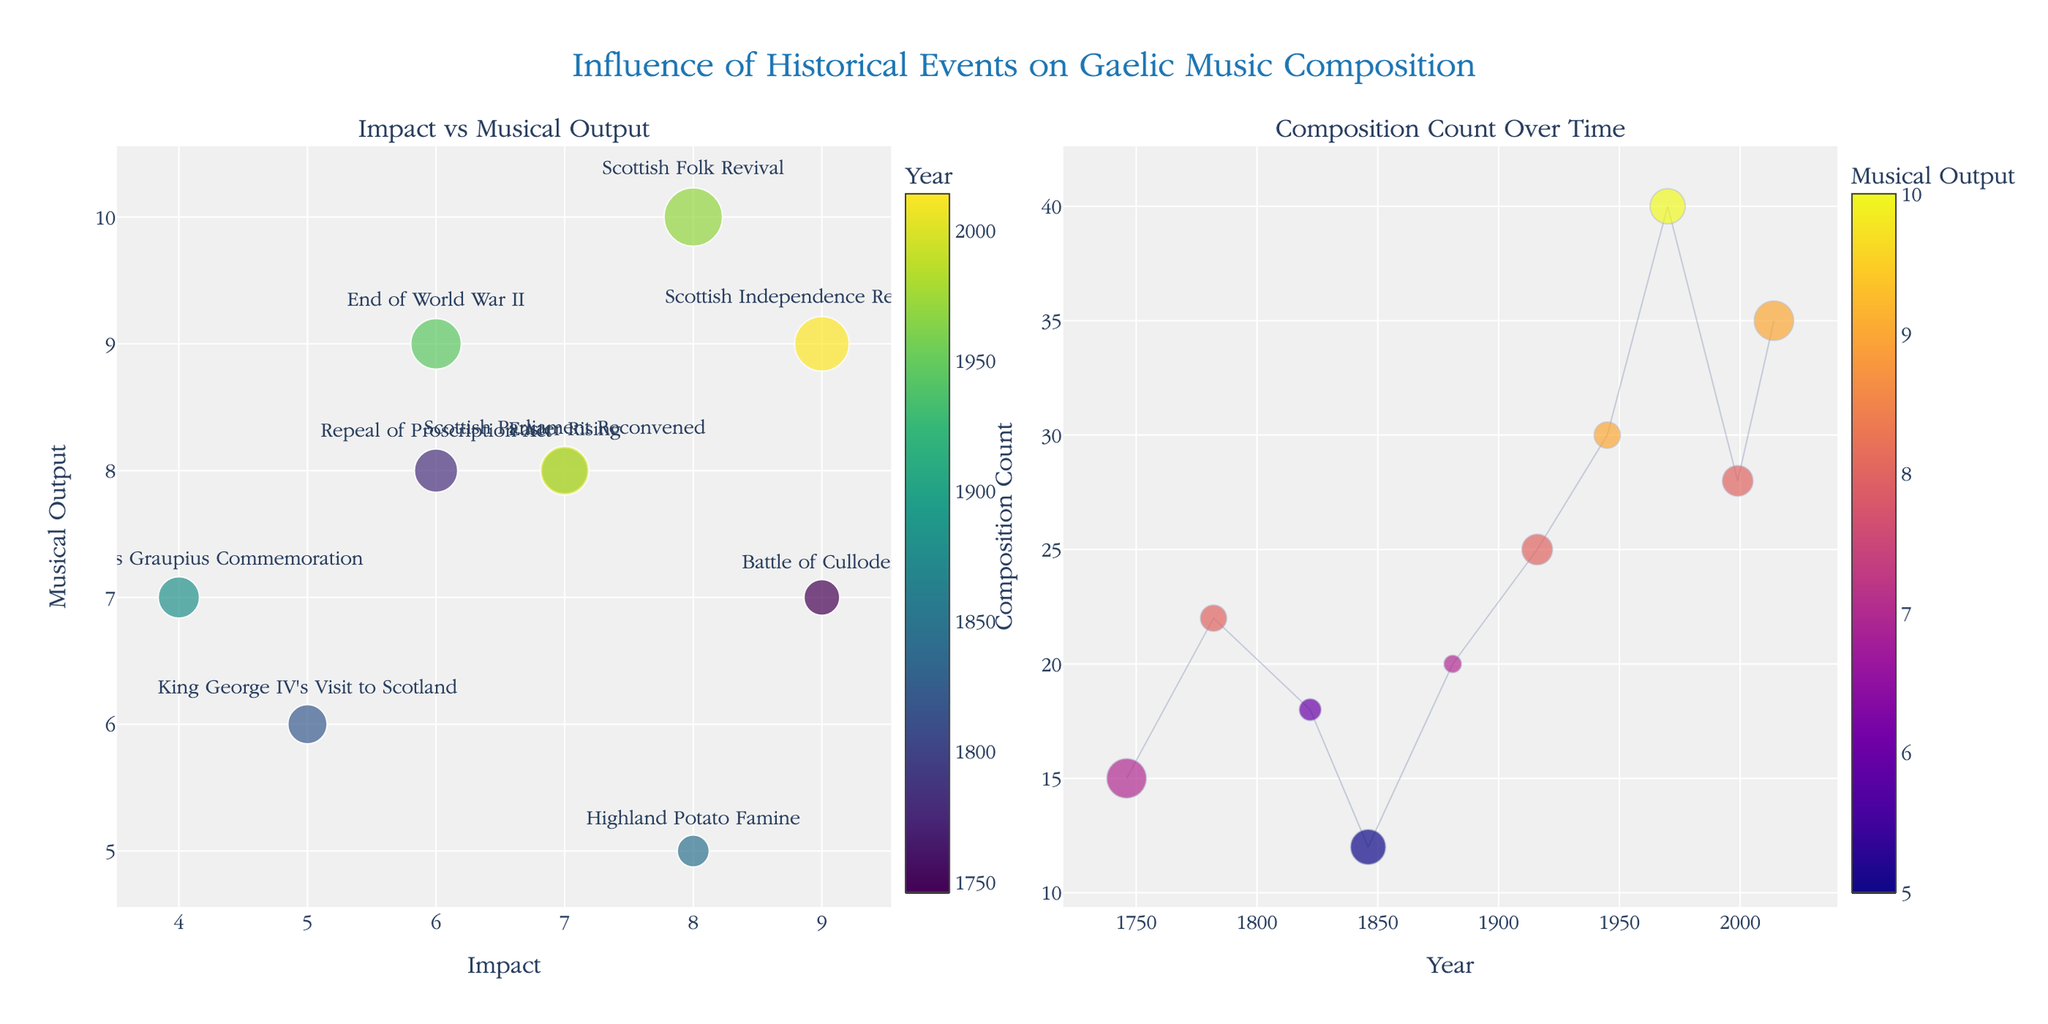What's the title of the figure? The title is displayed at the top center of the figure and reads, "Influence of Historical Events on Gaelic Music Composition".
Answer: Influence of Historical Events on Gaelic Music Composition Which event had the highest musical output? From the first subplot where "Musical Output" is on the y-axis, the event with the highest y-position is "Scottish Folk Revival" in 1970.
Answer: Scottish Folk Revival How many compositions were there in the year 1999? In the second subplot where "Year" is on the x-axis and "Composition Count" is on the y-axis, look at x=1999, which corresponds to a composition count of 28.
Answer: 28 Which event showed the largest bubble in the first subplot? The largest bubbles correspond to the highest "Composition Count". The event with the largest bubble is "Scottish Folk Revival" in 1970.
Answer: Scottish Folk Revival Which events happened before the 19th century? Checking the years in both subplots, the events before 1800 are "Battle of Culloden" (1746) and "Repeal of Proscription Act" (1782).
Answer: Battle of Culloden, Repeal of Proscription Act What is the relationship between impact and musical output for the "Battle of Culloden"? In the first subplot, find the bubble labeled "Battle of Culloden". The x-coordinate gives the impact (9) and the y-coordinate gives the musical output (7).
Answer: Impact: 9, Musical Output: 7 Compare the composition counts in 1916 and 2014. In the second subplot, find the points at x=1916 and x=2014. The corresponding composition counts are 25 and 35, respectively.
Answer: 1916: 25, 2014: 35 How does the "Highland Potato Famine" compare to "King George IV's Visit to Scotland" in terms of composition counts? In the second subplot, look at x=1846 and x=1822; the composition counts are 12 and 18, respectively.
Answer: Highland Potato Famine: 12, King George IV's Visit to Scotland: 18 What is the median impact value for the events shown? The impact values are 9, 6, 5, 8, 4, 7, 6, 8, 7, 9. Sorting them: 4, 5, 6, 6, 7, 7, 8, 8, 9, 9. The median is the average of the 5th and 6th values: (7+7)/2 = 7.
Answer: 7 What is unique about the bubble size of "Scottish Folk Revival"? It has the largest bubble size in the first subplot, indicating the highest composition count of 40.
Answer: Largest bubble size 